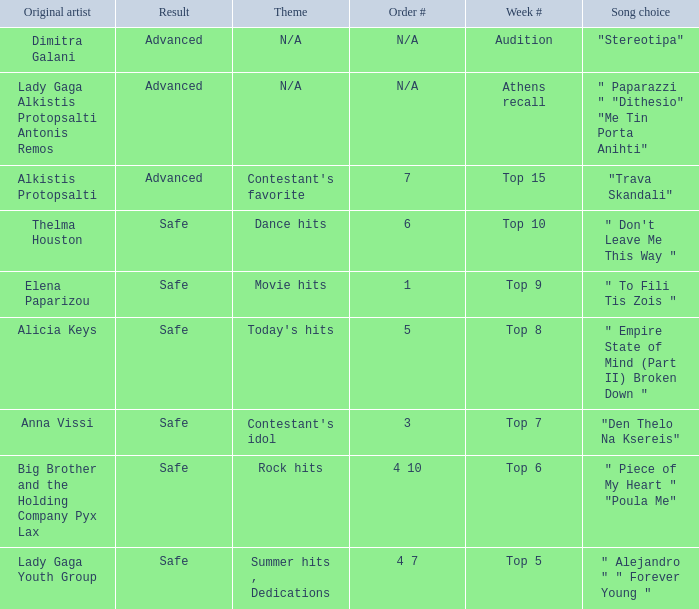Could you parse the entire table? {'header': ['Original artist', 'Result', 'Theme', 'Order #', 'Week #', 'Song choice'], 'rows': [['Dimitra Galani', 'Advanced', 'N/A', 'N/A', 'Audition', '"Stereotipa"'], ['Lady Gaga Alkistis Protopsalti Antonis Remos', 'Advanced', 'N/A', 'N/A', 'Athens recall', '" Paparazzi " "Dithesio" "Me Tin Porta Anihti"'], ['Alkistis Protopsalti', 'Advanced', "Contestant's favorite", '7', 'Top 15', '"Trava Skandali"'], ['Thelma Houston', 'Safe', 'Dance hits', '6', 'Top 10', '" Don\'t Leave Me This Way "'], ['Elena Paparizou', 'Safe', 'Movie hits', '1', 'Top 9', '" To Fili Tis Zois "'], ['Alicia Keys', 'Safe', "Today's hits", '5', 'Top 8', '" Empire State of Mind (Part II) Broken Down "'], ['Anna Vissi', 'Safe', "Contestant's idol", '3', 'Top 7', '"Den Thelo Na Ksereis"'], ['Big Brother and the Holding Company Pyx Lax', 'Safe', 'Rock hits', '4 10', 'Top 6', '" Piece of My Heart " "Poula Me"'], ['Lady Gaga Youth Group', 'Safe', 'Summer hits , Dedications', '4 7', 'Top 5', '" Alejandro " " Forever Young "']]} What are all the order #s from the week "top 6"? 4 10. 